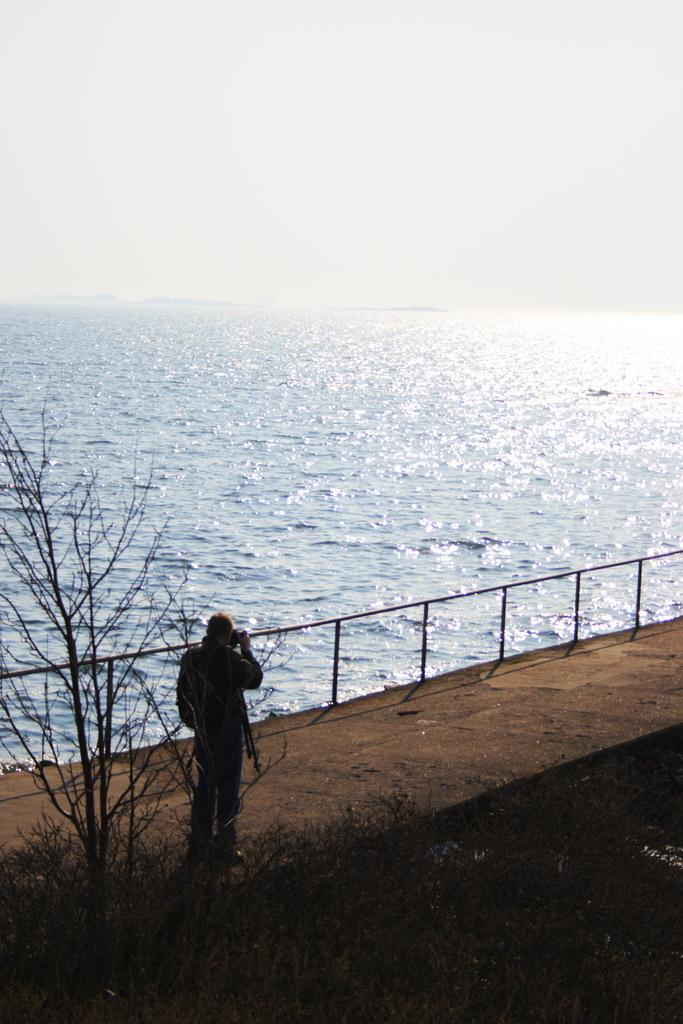What is the main subject of the image? The main subject of the image is a man. Where is the man located in the image? The man is standing on a bridge. What can be seen beside the man? There is water visible beside the man. What type of vegetation is present in the image? There is a tree in the image. What type of rat can be seen wearing a hot badge in the image? There is no rat present in the image, nor is there any mention of a badge or temperature. 